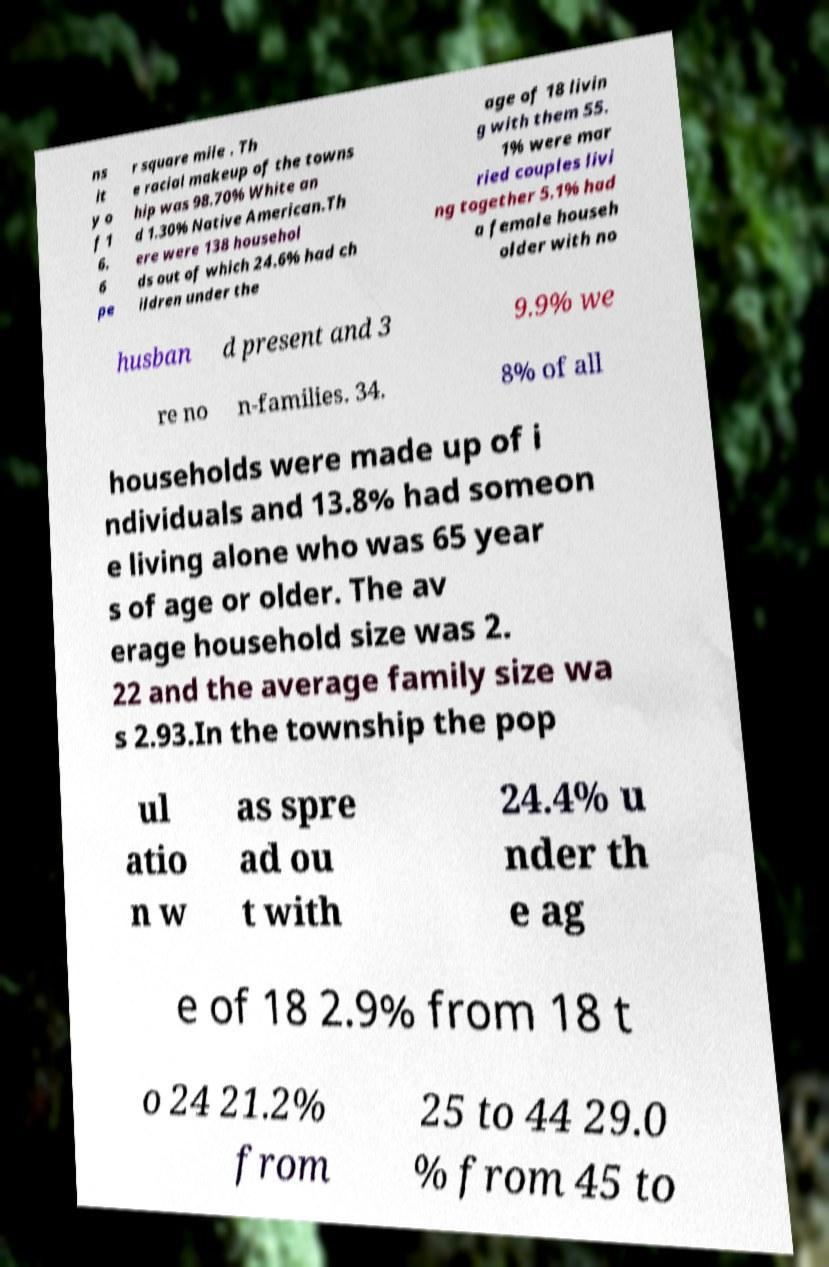There's text embedded in this image that I need extracted. Can you transcribe it verbatim? ns it y o f 1 6. 6 pe r square mile . Th e racial makeup of the towns hip was 98.70% White an d 1.30% Native American.Th ere were 138 househol ds out of which 24.6% had ch ildren under the age of 18 livin g with them 55. 1% were mar ried couples livi ng together 5.1% had a female househ older with no husban d present and 3 9.9% we re no n-families. 34. 8% of all households were made up of i ndividuals and 13.8% had someon e living alone who was 65 year s of age or older. The av erage household size was 2. 22 and the average family size wa s 2.93.In the township the pop ul atio n w as spre ad ou t with 24.4% u nder th e ag e of 18 2.9% from 18 t o 24 21.2% from 25 to 44 29.0 % from 45 to 